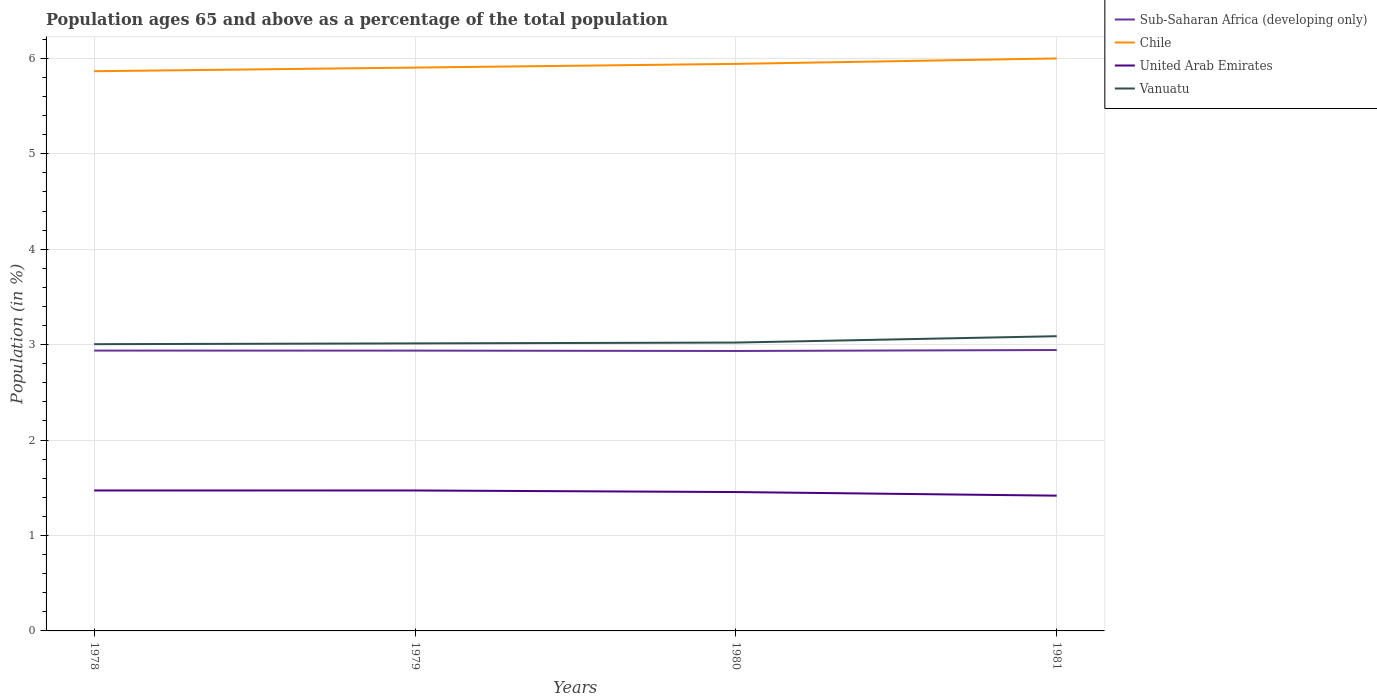Is the number of lines equal to the number of legend labels?
Give a very brief answer. Yes. Across all years, what is the maximum percentage of the population ages 65 and above in Vanuatu?
Offer a very short reply. 3. What is the total percentage of the population ages 65 and above in Sub-Saharan Africa (developing only) in the graph?
Keep it short and to the point. 0. What is the difference between the highest and the second highest percentage of the population ages 65 and above in Sub-Saharan Africa (developing only)?
Give a very brief answer. 0.01. What is the difference between the highest and the lowest percentage of the population ages 65 and above in Vanuatu?
Provide a short and direct response. 1. Does the graph contain any zero values?
Offer a terse response. No. Does the graph contain grids?
Ensure brevity in your answer.  Yes. Where does the legend appear in the graph?
Make the answer very short. Top right. How many legend labels are there?
Keep it short and to the point. 4. How are the legend labels stacked?
Your answer should be compact. Vertical. What is the title of the graph?
Your response must be concise. Population ages 65 and above as a percentage of the total population. Does "Nicaragua" appear as one of the legend labels in the graph?
Your answer should be very brief. No. What is the label or title of the X-axis?
Ensure brevity in your answer.  Years. What is the Population (in %) in Sub-Saharan Africa (developing only) in 1978?
Offer a very short reply. 2.94. What is the Population (in %) in Chile in 1978?
Make the answer very short. 5.86. What is the Population (in %) of United Arab Emirates in 1978?
Your response must be concise. 1.47. What is the Population (in %) of Vanuatu in 1978?
Give a very brief answer. 3. What is the Population (in %) of Sub-Saharan Africa (developing only) in 1979?
Offer a terse response. 2.94. What is the Population (in %) in Chile in 1979?
Offer a terse response. 5.9. What is the Population (in %) in United Arab Emirates in 1979?
Provide a short and direct response. 1.47. What is the Population (in %) in Vanuatu in 1979?
Offer a terse response. 3.01. What is the Population (in %) of Sub-Saharan Africa (developing only) in 1980?
Your answer should be compact. 2.93. What is the Population (in %) in Chile in 1980?
Your response must be concise. 5.94. What is the Population (in %) in United Arab Emirates in 1980?
Give a very brief answer. 1.46. What is the Population (in %) in Vanuatu in 1980?
Ensure brevity in your answer.  3.02. What is the Population (in %) of Sub-Saharan Africa (developing only) in 1981?
Your response must be concise. 2.94. What is the Population (in %) in Chile in 1981?
Your answer should be compact. 6. What is the Population (in %) of United Arab Emirates in 1981?
Your answer should be very brief. 1.42. What is the Population (in %) of Vanuatu in 1981?
Give a very brief answer. 3.09. Across all years, what is the maximum Population (in %) in Sub-Saharan Africa (developing only)?
Provide a succinct answer. 2.94. Across all years, what is the maximum Population (in %) of Chile?
Provide a short and direct response. 6. Across all years, what is the maximum Population (in %) of United Arab Emirates?
Your answer should be compact. 1.47. Across all years, what is the maximum Population (in %) of Vanuatu?
Give a very brief answer. 3.09. Across all years, what is the minimum Population (in %) in Sub-Saharan Africa (developing only)?
Offer a very short reply. 2.93. Across all years, what is the minimum Population (in %) of Chile?
Provide a short and direct response. 5.86. Across all years, what is the minimum Population (in %) of United Arab Emirates?
Your response must be concise. 1.42. Across all years, what is the minimum Population (in %) of Vanuatu?
Ensure brevity in your answer.  3. What is the total Population (in %) in Sub-Saharan Africa (developing only) in the graph?
Offer a terse response. 11.75. What is the total Population (in %) in Chile in the graph?
Provide a succinct answer. 23.71. What is the total Population (in %) in United Arab Emirates in the graph?
Offer a terse response. 5.82. What is the total Population (in %) in Vanuatu in the graph?
Keep it short and to the point. 12.13. What is the difference between the Population (in %) of Sub-Saharan Africa (developing only) in 1978 and that in 1979?
Give a very brief answer. 0. What is the difference between the Population (in %) in Chile in 1978 and that in 1979?
Keep it short and to the point. -0.04. What is the difference between the Population (in %) of United Arab Emirates in 1978 and that in 1979?
Your response must be concise. -0. What is the difference between the Population (in %) of Vanuatu in 1978 and that in 1979?
Make the answer very short. -0.01. What is the difference between the Population (in %) in Sub-Saharan Africa (developing only) in 1978 and that in 1980?
Offer a very short reply. 0. What is the difference between the Population (in %) of Chile in 1978 and that in 1980?
Offer a terse response. -0.08. What is the difference between the Population (in %) in United Arab Emirates in 1978 and that in 1980?
Provide a succinct answer. 0.02. What is the difference between the Population (in %) of Vanuatu in 1978 and that in 1980?
Offer a very short reply. -0.02. What is the difference between the Population (in %) of Sub-Saharan Africa (developing only) in 1978 and that in 1981?
Offer a very short reply. -0.01. What is the difference between the Population (in %) in Chile in 1978 and that in 1981?
Your answer should be compact. -0.13. What is the difference between the Population (in %) of United Arab Emirates in 1978 and that in 1981?
Your answer should be compact. 0.05. What is the difference between the Population (in %) in Vanuatu in 1978 and that in 1981?
Your answer should be very brief. -0.08. What is the difference between the Population (in %) in Sub-Saharan Africa (developing only) in 1979 and that in 1980?
Provide a short and direct response. 0. What is the difference between the Population (in %) of Chile in 1979 and that in 1980?
Give a very brief answer. -0.04. What is the difference between the Population (in %) of United Arab Emirates in 1979 and that in 1980?
Provide a short and direct response. 0.02. What is the difference between the Population (in %) in Vanuatu in 1979 and that in 1980?
Keep it short and to the point. -0.01. What is the difference between the Population (in %) in Sub-Saharan Africa (developing only) in 1979 and that in 1981?
Your response must be concise. -0.01. What is the difference between the Population (in %) in Chile in 1979 and that in 1981?
Your answer should be very brief. -0.1. What is the difference between the Population (in %) of United Arab Emirates in 1979 and that in 1981?
Ensure brevity in your answer.  0.05. What is the difference between the Population (in %) in Vanuatu in 1979 and that in 1981?
Provide a short and direct response. -0.08. What is the difference between the Population (in %) in Sub-Saharan Africa (developing only) in 1980 and that in 1981?
Your answer should be very brief. -0.01. What is the difference between the Population (in %) of Chile in 1980 and that in 1981?
Your answer should be very brief. -0.06. What is the difference between the Population (in %) of United Arab Emirates in 1980 and that in 1981?
Ensure brevity in your answer.  0.04. What is the difference between the Population (in %) of Vanuatu in 1980 and that in 1981?
Your answer should be compact. -0.07. What is the difference between the Population (in %) in Sub-Saharan Africa (developing only) in 1978 and the Population (in %) in Chile in 1979?
Offer a very short reply. -2.97. What is the difference between the Population (in %) of Sub-Saharan Africa (developing only) in 1978 and the Population (in %) of United Arab Emirates in 1979?
Offer a very short reply. 1.47. What is the difference between the Population (in %) in Sub-Saharan Africa (developing only) in 1978 and the Population (in %) in Vanuatu in 1979?
Offer a terse response. -0.08. What is the difference between the Population (in %) of Chile in 1978 and the Population (in %) of United Arab Emirates in 1979?
Provide a succinct answer. 4.39. What is the difference between the Population (in %) in Chile in 1978 and the Population (in %) in Vanuatu in 1979?
Provide a succinct answer. 2.85. What is the difference between the Population (in %) of United Arab Emirates in 1978 and the Population (in %) of Vanuatu in 1979?
Provide a short and direct response. -1.54. What is the difference between the Population (in %) of Sub-Saharan Africa (developing only) in 1978 and the Population (in %) of Chile in 1980?
Provide a succinct answer. -3. What is the difference between the Population (in %) of Sub-Saharan Africa (developing only) in 1978 and the Population (in %) of United Arab Emirates in 1980?
Provide a succinct answer. 1.48. What is the difference between the Population (in %) of Sub-Saharan Africa (developing only) in 1978 and the Population (in %) of Vanuatu in 1980?
Ensure brevity in your answer.  -0.08. What is the difference between the Population (in %) of Chile in 1978 and the Population (in %) of United Arab Emirates in 1980?
Provide a succinct answer. 4.41. What is the difference between the Population (in %) in Chile in 1978 and the Population (in %) in Vanuatu in 1980?
Provide a succinct answer. 2.84. What is the difference between the Population (in %) of United Arab Emirates in 1978 and the Population (in %) of Vanuatu in 1980?
Provide a short and direct response. -1.55. What is the difference between the Population (in %) in Sub-Saharan Africa (developing only) in 1978 and the Population (in %) in Chile in 1981?
Your answer should be very brief. -3.06. What is the difference between the Population (in %) of Sub-Saharan Africa (developing only) in 1978 and the Population (in %) of United Arab Emirates in 1981?
Make the answer very short. 1.52. What is the difference between the Population (in %) in Sub-Saharan Africa (developing only) in 1978 and the Population (in %) in Vanuatu in 1981?
Offer a very short reply. -0.15. What is the difference between the Population (in %) in Chile in 1978 and the Population (in %) in United Arab Emirates in 1981?
Your answer should be compact. 4.45. What is the difference between the Population (in %) of Chile in 1978 and the Population (in %) of Vanuatu in 1981?
Keep it short and to the point. 2.78. What is the difference between the Population (in %) of United Arab Emirates in 1978 and the Population (in %) of Vanuatu in 1981?
Provide a succinct answer. -1.62. What is the difference between the Population (in %) in Sub-Saharan Africa (developing only) in 1979 and the Population (in %) in Chile in 1980?
Your response must be concise. -3. What is the difference between the Population (in %) of Sub-Saharan Africa (developing only) in 1979 and the Population (in %) of United Arab Emirates in 1980?
Ensure brevity in your answer.  1.48. What is the difference between the Population (in %) in Sub-Saharan Africa (developing only) in 1979 and the Population (in %) in Vanuatu in 1980?
Provide a succinct answer. -0.08. What is the difference between the Population (in %) of Chile in 1979 and the Population (in %) of United Arab Emirates in 1980?
Keep it short and to the point. 4.45. What is the difference between the Population (in %) in Chile in 1979 and the Population (in %) in Vanuatu in 1980?
Offer a terse response. 2.88. What is the difference between the Population (in %) of United Arab Emirates in 1979 and the Population (in %) of Vanuatu in 1980?
Ensure brevity in your answer.  -1.55. What is the difference between the Population (in %) of Sub-Saharan Africa (developing only) in 1979 and the Population (in %) of Chile in 1981?
Your response must be concise. -3.06. What is the difference between the Population (in %) of Sub-Saharan Africa (developing only) in 1979 and the Population (in %) of United Arab Emirates in 1981?
Your answer should be compact. 1.52. What is the difference between the Population (in %) in Sub-Saharan Africa (developing only) in 1979 and the Population (in %) in Vanuatu in 1981?
Offer a terse response. -0.15. What is the difference between the Population (in %) of Chile in 1979 and the Population (in %) of United Arab Emirates in 1981?
Provide a succinct answer. 4.49. What is the difference between the Population (in %) of Chile in 1979 and the Population (in %) of Vanuatu in 1981?
Provide a short and direct response. 2.81. What is the difference between the Population (in %) of United Arab Emirates in 1979 and the Population (in %) of Vanuatu in 1981?
Offer a terse response. -1.62. What is the difference between the Population (in %) in Sub-Saharan Africa (developing only) in 1980 and the Population (in %) in Chile in 1981?
Ensure brevity in your answer.  -3.07. What is the difference between the Population (in %) of Sub-Saharan Africa (developing only) in 1980 and the Population (in %) of United Arab Emirates in 1981?
Offer a terse response. 1.52. What is the difference between the Population (in %) of Sub-Saharan Africa (developing only) in 1980 and the Population (in %) of Vanuatu in 1981?
Keep it short and to the point. -0.15. What is the difference between the Population (in %) of Chile in 1980 and the Population (in %) of United Arab Emirates in 1981?
Your answer should be very brief. 4.52. What is the difference between the Population (in %) in Chile in 1980 and the Population (in %) in Vanuatu in 1981?
Make the answer very short. 2.85. What is the difference between the Population (in %) in United Arab Emirates in 1980 and the Population (in %) in Vanuatu in 1981?
Offer a terse response. -1.63. What is the average Population (in %) in Sub-Saharan Africa (developing only) per year?
Provide a short and direct response. 2.94. What is the average Population (in %) of Chile per year?
Your answer should be very brief. 5.93. What is the average Population (in %) of United Arab Emirates per year?
Give a very brief answer. 1.45. What is the average Population (in %) of Vanuatu per year?
Your answer should be very brief. 3.03. In the year 1978, what is the difference between the Population (in %) of Sub-Saharan Africa (developing only) and Population (in %) of Chile?
Your response must be concise. -2.93. In the year 1978, what is the difference between the Population (in %) of Sub-Saharan Africa (developing only) and Population (in %) of United Arab Emirates?
Provide a short and direct response. 1.47. In the year 1978, what is the difference between the Population (in %) of Sub-Saharan Africa (developing only) and Population (in %) of Vanuatu?
Make the answer very short. -0.07. In the year 1978, what is the difference between the Population (in %) in Chile and Population (in %) in United Arab Emirates?
Your answer should be very brief. 4.39. In the year 1978, what is the difference between the Population (in %) in Chile and Population (in %) in Vanuatu?
Your answer should be compact. 2.86. In the year 1978, what is the difference between the Population (in %) in United Arab Emirates and Population (in %) in Vanuatu?
Your answer should be very brief. -1.53. In the year 1979, what is the difference between the Population (in %) in Sub-Saharan Africa (developing only) and Population (in %) in Chile?
Keep it short and to the point. -2.97. In the year 1979, what is the difference between the Population (in %) in Sub-Saharan Africa (developing only) and Population (in %) in United Arab Emirates?
Keep it short and to the point. 1.47. In the year 1979, what is the difference between the Population (in %) in Sub-Saharan Africa (developing only) and Population (in %) in Vanuatu?
Ensure brevity in your answer.  -0.08. In the year 1979, what is the difference between the Population (in %) in Chile and Population (in %) in United Arab Emirates?
Your answer should be very brief. 4.43. In the year 1979, what is the difference between the Population (in %) of Chile and Population (in %) of Vanuatu?
Keep it short and to the point. 2.89. In the year 1979, what is the difference between the Population (in %) of United Arab Emirates and Population (in %) of Vanuatu?
Provide a succinct answer. -1.54. In the year 1980, what is the difference between the Population (in %) of Sub-Saharan Africa (developing only) and Population (in %) of Chile?
Provide a short and direct response. -3.01. In the year 1980, what is the difference between the Population (in %) of Sub-Saharan Africa (developing only) and Population (in %) of United Arab Emirates?
Ensure brevity in your answer.  1.48. In the year 1980, what is the difference between the Population (in %) in Sub-Saharan Africa (developing only) and Population (in %) in Vanuatu?
Provide a short and direct response. -0.09. In the year 1980, what is the difference between the Population (in %) of Chile and Population (in %) of United Arab Emirates?
Provide a short and direct response. 4.49. In the year 1980, what is the difference between the Population (in %) of Chile and Population (in %) of Vanuatu?
Your response must be concise. 2.92. In the year 1980, what is the difference between the Population (in %) of United Arab Emirates and Population (in %) of Vanuatu?
Ensure brevity in your answer.  -1.57. In the year 1981, what is the difference between the Population (in %) of Sub-Saharan Africa (developing only) and Population (in %) of Chile?
Make the answer very short. -3.06. In the year 1981, what is the difference between the Population (in %) in Sub-Saharan Africa (developing only) and Population (in %) in United Arab Emirates?
Ensure brevity in your answer.  1.53. In the year 1981, what is the difference between the Population (in %) in Sub-Saharan Africa (developing only) and Population (in %) in Vanuatu?
Provide a succinct answer. -0.14. In the year 1981, what is the difference between the Population (in %) in Chile and Population (in %) in United Arab Emirates?
Make the answer very short. 4.58. In the year 1981, what is the difference between the Population (in %) of Chile and Population (in %) of Vanuatu?
Keep it short and to the point. 2.91. In the year 1981, what is the difference between the Population (in %) of United Arab Emirates and Population (in %) of Vanuatu?
Keep it short and to the point. -1.67. What is the ratio of the Population (in %) in Sub-Saharan Africa (developing only) in 1978 to that in 1979?
Provide a short and direct response. 1. What is the ratio of the Population (in %) in Chile in 1978 to that in 1979?
Your answer should be compact. 0.99. What is the ratio of the Population (in %) of United Arab Emirates in 1978 to that in 1979?
Your answer should be compact. 1. What is the ratio of the Population (in %) in Sub-Saharan Africa (developing only) in 1978 to that in 1980?
Keep it short and to the point. 1. What is the ratio of the Population (in %) in Chile in 1978 to that in 1980?
Give a very brief answer. 0.99. What is the ratio of the Population (in %) in United Arab Emirates in 1978 to that in 1980?
Give a very brief answer. 1.01. What is the ratio of the Population (in %) of Chile in 1978 to that in 1981?
Give a very brief answer. 0.98. What is the ratio of the Population (in %) of United Arab Emirates in 1978 to that in 1981?
Your answer should be very brief. 1.04. What is the ratio of the Population (in %) in Vanuatu in 1978 to that in 1981?
Make the answer very short. 0.97. What is the ratio of the Population (in %) in Chile in 1979 to that in 1980?
Provide a short and direct response. 0.99. What is the ratio of the Population (in %) of United Arab Emirates in 1979 to that in 1980?
Your answer should be compact. 1.01. What is the ratio of the Population (in %) of Vanuatu in 1979 to that in 1980?
Make the answer very short. 1. What is the ratio of the Population (in %) in United Arab Emirates in 1979 to that in 1981?
Offer a terse response. 1.04. What is the ratio of the Population (in %) of Vanuatu in 1979 to that in 1981?
Your response must be concise. 0.98. What is the ratio of the Population (in %) of United Arab Emirates in 1980 to that in 1981?
Your response must be concise. 1.03. What is the ratio of the Population (in %) in Vanuatu in 1980 to that in 1981?
Provide a succinct answer. 0.98. What is the difference between the highest and the second highest Population (in %) in Sub-Saharan Africa (developing only)?
Make the answer very short. 0.01. What is the difference between the highest and the second highest Population (in %) of Chile?
Your answer should be compact. 0.06. What is the difference between the highest and the second highest Population (in %) of Vanuatu?
Offer a very short reply. 0.07. What is the difference between the highest and the lowest Population (in %) in Sub-Saharan Africa (developing only)?
Your response must be concise. 0.01. What is the difference between the highest and the lowest Population (in %) in Chile?
Your answer should be very brief. 0.13. What is the difference between the highest and the lowest Population (in %) of United Arab Emirates?
Keep it short and to the point. 0.05. What is the difference between the highest and the lowest Population (in %) in Vanuatu?
Ensure brevity in your answer.  0.08. 